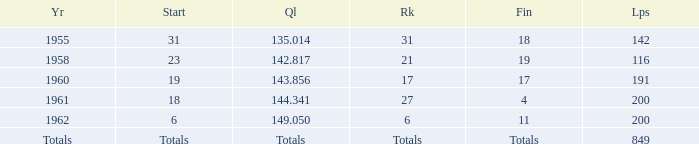Parse the full table. {'header': ['Yr', 'Start', 'Ql', 'Rk', 'Fin', 'Lps'], 'rows': [['1955', '31', '135.014', '31', '18', '142'], ['1958', '23', '142.817', '21', '19', '116'], ['1960', '19', '143.856', '17', '17', '191'], ['1961', '18', '144.341', '27', '4', '200'], ['1962', '6', '149.050', '6', '11', '200'], ['Totals', 'Totals', 'Totals', 'Totals', 'Totals', '849']]} What year has a finish of 19? 1958.0. 